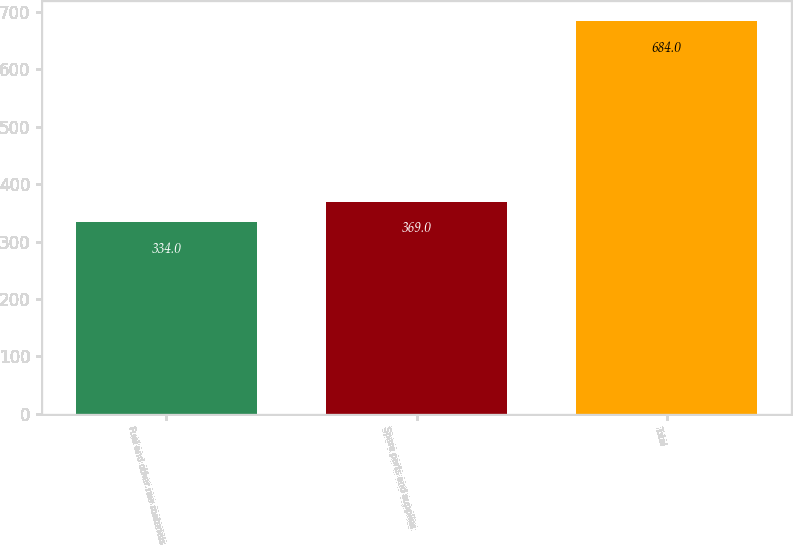Convert chart to OTSL. <chart><loc_0><loc_0><loc_500><loc_500><bar_chart><fcel>Fuel and other raw materials<fcel>Spare parts and supplies<fcel>Total<nl><fcel>334<fcel>369<fcel>684<nl></chart> 